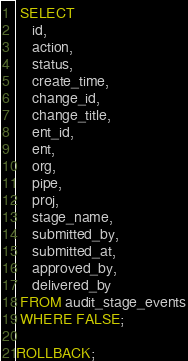<code> <loc_0><loc_0><loc_500><loc_500><_SQL_>
 SELECT
    id,
    action,
    status,
    create_time,
    change_id,
    change_title,
    ent_id,
    ent,
    org,
    pipe,
    proj,
    stage_name,
    submitted_by,
    submitted_at,
    approved_by,
    delivered_by
 FROM audit_stage_events
 WHERE FALSE;

ROLLBACK;
</code> 